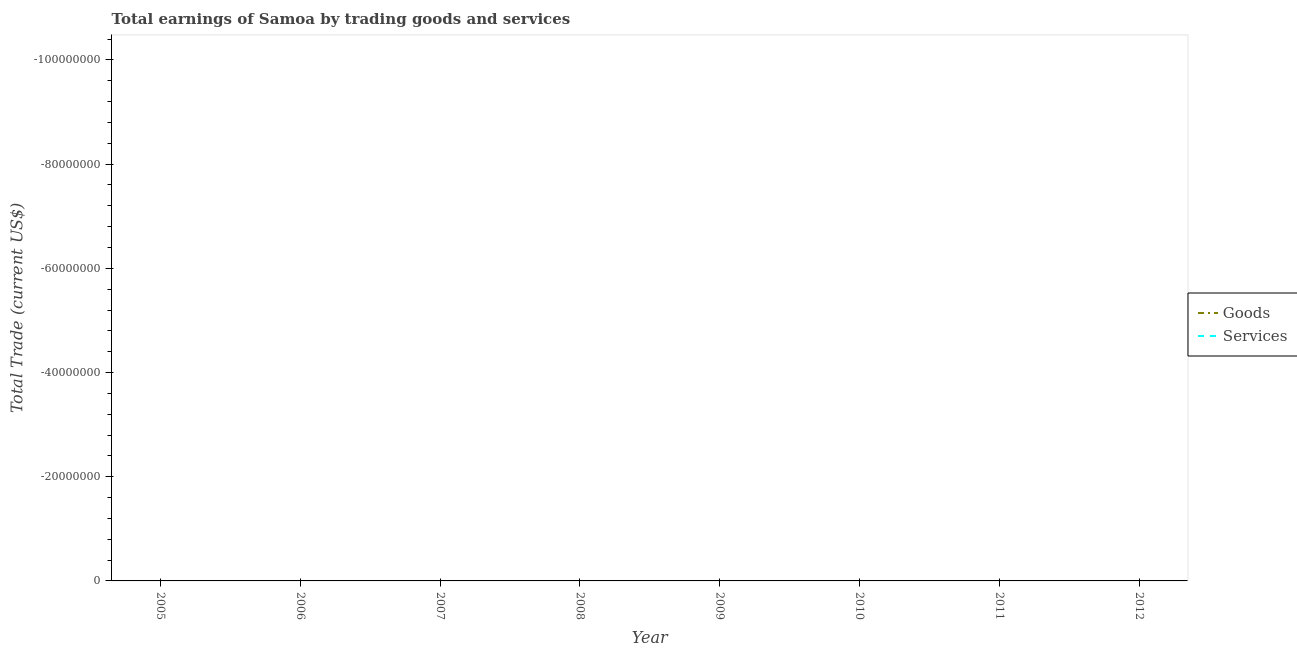How many different coloured lines are there?
Make the answer very short. 0. Is the number of lines equal to the number of legend labels?
Provide a short and direct response. No. What is the amount earned by trading services in 2005?
Your answer should be compact. 0. Across all years, what is the minimum amount earned by trading services?
Give a very brief answer. 0. What is the total amount earned by trading goods in the graph?
Provide a short and direct response. 0. What is the average amount earned by trading services per year?
Offer a terse response. 0. Does the amount earned by trading services monotonically increase over the years?
Offer a terse response. No. Is the amount earned by trading goods strictly greater than the amount earned by trading services over the years?
Your answer should be compact. No. Is the amount earned by trading goods strictly less than the amount earned by trading services over the years?
Give a very brief answer. Yes. How many years are there in the graph?
Provide a succinct answer. 8. What is the difference between two consecutive major ticks on the Y-axis?
Provide a short and direct response. 2.00e+07. Does the graph contain any zero values?
Keep it short and to the point. Yes. Does the graph contain grids?
Make the answer very short. No. How are the legend labels stacked?
Give a very brief answer. Vertical. What is the title of the graph?
Provide a short and direct response. Total earnings of Samoa by trading goods and services. What is the label or title of the Y-axis?
Keep it short and to the point. Total Trade (current US$). What is the Total Trade (current US$) in Goods in 2007?
Your answer should be compact. 0. What is the Total Trade (current US$) of Services in 2007?
Make the answer very short. 0. What is the Total Trade (current US$) of Goods in 2008?
Make the answer very short. 0. What is the Total Trade (current US$) in Goods in 2009?
Ensure brevity in your answer.  0. What is the Total Trade (current US$) in Goods in 2011?
Give a very brief answer. 0. What is the Total Trade (current US$) of Goods in 2012?
Offer a very short reply. 0. What is the total Total Trade (current US$) of Goods in the graph?
Make the answer very short. 0. What is the average Total Trade (current US$) in Goods per year?
Provide a succinct answer. 0. 